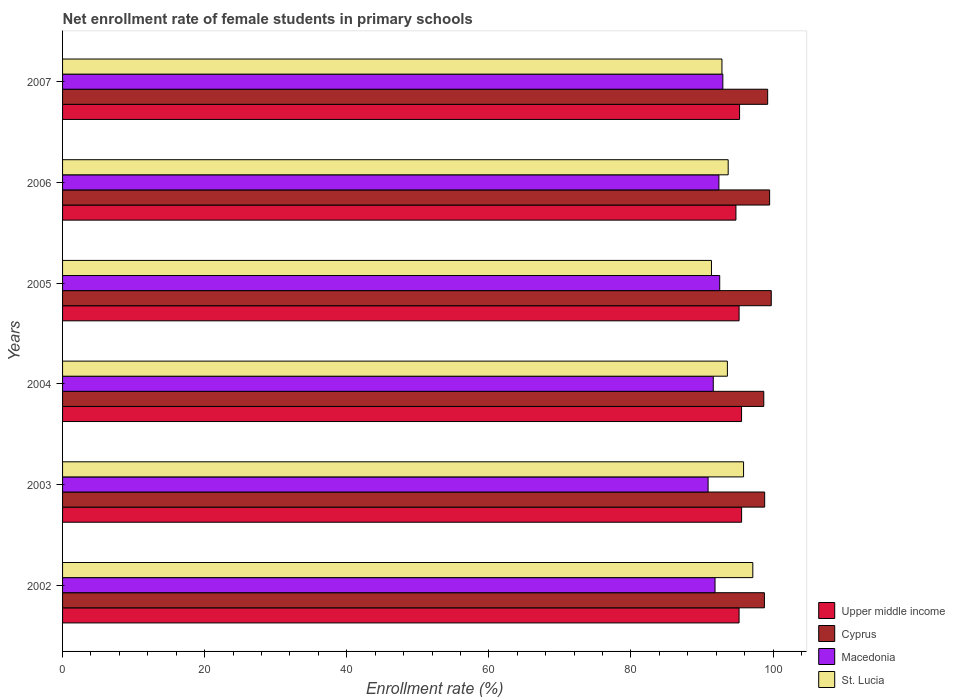How many groups of bars are there?
Offer a terse response. 6. Are the number of bars per tick equal to the number of legend labels?
Your answer should be very brief. Yes. How many bars are there on the 1st tick from the bottom?
Offer a very short reply. 4. What is the label of the 4th group of bars from the top?
Give a very brief answer. 2004. In how many cases, is the number of bars for a given year not equal to the number of legend labels?
Ensure brevity in your answer.  0. What is the net enrollment rate of female students in primary schools in Cyprus in 2003?
Ensure brevity in your answer.  98.82. Across all years, what is the maximum net enrollment rate of female students in primary schools in Cyprus?
Keep it short and to the point. 99.75. Across all years, what is the minimum net enrollment rate of female students in primary schools in Macedonia?
Make the answer very short. 90.86. In which year was the net enrollment rate of female students in primary schools in St. Lucia maximum?
Your answer should be compact. 2002. In which year was the net enrollment rate of female students in primary schools in Macedonia minimum?
Give a very brief answer. 2003. What is the total net enrollment rate of female students in primary schools in Macedonia in the graph?
Provide a succinct answer. 552.08. What is the difference between the net enrollment rate of female students in primary schools in St. Lucia in 2005 and that in 2007?
Ensure brevity in your answer.  -1.48. What is the difference between the net enrollment rate of female students in primary schools in St. Lucia in 2004 and the net enrollment rate of female students in primary schools in Macedonia in 2005?
Provide a short and direct response. 1.08. What is the average net enrollment rate of female students in primary schools in Macedonia per year?
Ensure brevity in your answer.  92.01. In the year 2002, what is the difference between the net enrollment rate of female students in primary schools in Macedonia and net enrollment rate of female students in primary schools in Cyprus?
Keep it short and to the point. -6.95. In how many years, is the net enrollment rate of female students in primary schools in St. Lucia greater than 44 %?
Offer a very short reply. 6. What is the ratio of the net enrollment rate of female students in primary schools in Macedonia in 2005 to that in 2007?
Offer a terse response. 1. Is the net enrollment rate of female students in primary schools in Cyprus in 2004 less than that in 2005?
Your response must be concise. Yes. Is the difference between the net enrollment rate of female students in primary schools in Macedonia in 2002 and 2005 greater than the difference between the net enrollment rate of female students in primary schools in Cyprus in 2002 and 2005?
Give a very brief answer. Yes. What is the difference between the highest and the second highest net enrollment rate of female students in primary schools in Upper middle income?
Offer a very short reply. 0.01. What is the difference between the highest and the lowest net enrollment rate of female students in primary schools in St. Lucia?
Make the answer very short. 5.82. Is the sum of the net enrollment rate of female students in primary schools in St. Lucia in 2003 and 2007 greater than the maximum net enrollment rate of female students in primary schools in Macedonia across all years?
Give a very brief answer. Yes. Is it the case that in every year, the sum of the net enrollment rate of female students in primary schools in St. Lucia and net enrollment rate of female students in primary schools in Cyprus is greater than the sum of net enrollment rate of female students in primary schools in Upper middle income and net enrollment rate of female students in primary schools in Macedonia?
Offer a very short reply. No. What does the 1st bar from the top in 2003 represents?
Ensure brevity in your answer.  St. Lucia. What does the 3rd bar from the bottom in 2002 represents?
Offer a very short reply. Macedonia. Is it the case that in every year, the sum of the net enrollment rate of female students in primary schools in St. Lucia and net enrollment rate of female students in primary schools in Macedonia is greater than the net enrollment rate of female students in primary schools in Cyprus?
Provide a short and direct response. Yes. How many bars are there?
Offer a terse response. 24. Are all the bars in the graph horizontal?
Your answer should be compact. Yes. How many years are there in the graph?
Give a very brief answer. 6. Does the graph contain any zero values?
Make the answer very short. No. Does the graph contain grids?
Make the answer very short. No. Where does the legend appear in the graph?
Ensure brevity in your answer.  Bottom right. How many legend labels are there?
Keep it short and to the point. 4. How are the legend labels stacked?
Ensure brevity in your answer.  Vertical. What is the title of the graph?
Ensure brevity in your answer.  Net enrollment rate of female students in primary schools. Does "Armenia" appear as one of the legend labels in the graph?
Make the answer very short. No. What is the label or title of the X-axis?
Keep it short and to the point. Enrollment rate (%). What is the Enrollment rate (%) in Upper middle income in 2002?
Keep it short and to the point. 95.22. What is the Enrollment rate (%) of Cyprus in 2002?
Your response must be concise. 98.78. What is the Enrollment rate (%) of Macedonia in 2002?
Offer a terse response. 91.83. What is the Enrollment rate (%) of St. Lucia in 2002?
Keep it short and to the point. 97.15. What is the Enrollment rate (%) of Upper middle income in 2003?
Ensure brevity in your answer.  95.57. What is the Enrollment rate (%) of Cyprus in 2003?
Offer a terse response. 98.82. What is the Enrollment rate (%) in Macedonia in 2003?
Your answer should be very brief. 90.86. What is the Enrollment rate (%) in St. Lucia in 2003?
Your answer should be very brief. 95.85. What is the Enrollment rate (%) of Upper middle income in 2004?
Provide a succinct answer. 95.57. What is the Enrollment rate (%) of Cyprus in 2004?
Offer a very short reply. 98.69. What is the Enrollment rate (%) in Macedonia in 2004?
Provide a short and direct response. 91.58. What is the Enrollment rate (%) of St. Lucia in 2004?
Keep it short and to the point. 93.57. What is the Enrollment rate (%) of Upper middle income in 2005?
Provide a short and direct response. 95.22. What is the Enrollment rate (%) of Cyprus in 2005?
Keep it short and to the point. 99.75. What is the Enrollment rate (%) in Macedonia in 2005?
Provide a short and direct response. 92.49. What is the Enrollment rate (%) in St. Lucia in 2005?
Your response must be concise. 91.33. What is the Enrollment rate (%) of Upper middle income in 2006?
Offer a very short reply. 94.77. What is the Enrollment rate (%) in Cyprus in 2006?
Provide a short and direct response. 99.52. What is the Enrollment rate (%) in Macedonia in 2006?
Your answer should be compact. 92.38. What is the Enrollment rate (%) of St. Lucia in 2006?
Your answer should be very brief. 93.68. What is the Enrollment rate (%) in Upper middle income in 2007?
Offer a very short reply. 95.29. What is the Enrollment rate (%) of Cyprus in 2007?
Give a very brief answer. 99.24. What is the Enrollment rate (%) in Macedonia in 2007?
Provide a succinct answer. 92.93. What is the Enrollment rate (%) of St. Lucia in 2007?
Ensure brevity in your answer.  92.81. Across all years, what is the maximum Enrollment rate (%) in Upper middle income?
Provide a succinct answer. 95.57. Across all years, what is the maximum Enrollment rate (%) of Cyprus?
Offer a very short reply. 99.75. Across all years, what is the maximum Enrollment rate (%) in Macedonia?
Your answer should be compact. 92.93. Across all years, what is the maximum Enrollment rate (%) in St. Lucia?
Keep it short and to the point. 97.15. Across all years, what is the minimum Enrollment rate (%) of Upper middle income?
Your answer should be compact. 94.77. Across all years, what is the minimum Enrollment rate (%) in Cyprus?
Give a very brief answer. 98.69. Across all years, what is the minimum Enrollment rate (%) in Macedonia?
Your answer should be very brief. 90.86. Across all years, what is the minimum Enrollment rate (%) in St. Lucia?
Your answer should be very brief. 91.33. What is the total Enrollment rate (%) in Upper middle income in the graph?
Offer a very short reply. 571.64. What is the total Enrollment rate (%) of Cyprus in the graph?
Your answer should be very brief. 594.8. What is the total Enrollment rate (%) of Macedonia in the graph?
Keep it short and to the point. 552.08. What is the total Enrollment rate (%) in St. Lucia in the graph?
Your response must be concise. 564.39. What is the difference between the Enrollment rate (%) of Upper middle income in 2002 and that in 2003?
Your answer should be very brief. -0.36. What is the difference between the Enrollment rate (%) in Cyprus in 2002 and that in 2003?
Your answer should be compact. -0.04. What is the difference between the Enrollment rate (%) in Macedonia in 2002 and that in 2003?
Your response must be concise. 0.97. What is the difference between the Enrollment rate (%) of St. Lucia in 2002 and that in 2003?
Offer a very short reply. 1.3. What is the difference between the Enrollment rate (%) of Upper middle income in 2002 and that in 2004?
Your answer should be very brief. -0.35. What is the difference between the Enrollment rate (%) in Cyprus in 2002 and that in 2004?
Your answer should be very brief. 0.09. What is the difference between the Enrollment rate (%) of Macedonia in 2002 and that in 2004?
Keep it short and to the point. 0.25. What is the difference between the Enrollment rate (%) of St. Lucia in 2002 and that in 2004?
Ensure brevity in your answer.  3.58. What is the difference between the Enrollment rate (%) in Upper middle income in 2002 and that in 2005?
Your response must be concise. -0. What is the difference between the Enrollment rate (%) of Cyprus in 2002 and that in 2005?
Ensure brevity in your answer.  -0.97. What is the difference between the Enrollment rate (%) in Macedonia in 2002 and that in 2005?
Keep it short and to the point. -0.66. What is the difference between the Enrollment rate (%) of St. Lucia in 2002 and that in 2005?
Provide a succinct answer. 5.82. What is the difference between the Enrollment rate (%) of Upper middle income in 2002 and that in 2006?
Provide a short and direct response. 0.44. What is the difference between the Enrollment rate (%) in Cyprus in 2002 and that in 2006?
Make the answer very short. -0.74. What is the difference between the Enrollment rate (%) of Macedonia in 2002 and that in 2006?
Keep it short and to the point. -0.55. What is the difference between the Enrollment rate (%) in St. Lucia in 2002 and that in 2006?
Offer a very short reply. 3.47. What is the difference between the Enrollment rate (%) in Upper middle income in 2002 and that in 2007?
Provide a short and direct response. -0.07. What is the difference between the Enrollment rate (%) of Cyprus in 2002 and that in 2007?
Give a very brief answer. -0.46. What is the difference between the Enrollment rate (%) of Macedonia in 2002 and that in 2007?
Ensure brevity in your answer.  -1.1. What is the difference between the Enrollment rate (%) of St. Lucia in 2002 and that in 2007?
Offer a very short reply. 4.34. What is the difference between the Enrollment rate (%) of Upper middle income in 2003 and that in 2004?
Make the answer very short. 0.01. What is the difference between the Enrollment rate (%) of Cyprus in 2003 and that in 2004?
Your answer should be very brief. 0.13. What is the difference between the Enrollment rate (%) in Macedonia in 2003 and that in 2004?
Keep it short and to the point. -0.73. What is the difference between the Enrollment rate (%) of St. Lucia in 2003 and that in 2004?
Keep it short and to the point. 2.28. What is the difference between the Enrollment rate (%) in Upper middle income in 2003 and that in 2005?
Make the answer very short. 0.35. What is the difference between the Enrollment rate (%) in Cyprus in 2003 and that in 2005?
Offer a terse response. -0.93. What is the difference between the Enrollment rate (%) in Macedonia in 2003 and that in 2005?
Your answer should be very brief. -1.63. What is the difference between the Enrollment rate (%) of St. Lucia in 2003 and that in 2005?
Provide a succinct answer. 4.52. What is the difference between the Enrollment rate (%) of Upper middle income in 2003 and that in 2006?
Provide a succinct answer. 0.8. What is the difference between the Enrollment rate (%) in Cyprus in 2003 and that in 2006?
Make the answer very short. -0.7. What is the difference between the Enrollment rate (%) in Macedonia in 2003 and that in 2006?
Keep it short and to the point. -1.52. What is the difference between the Enrollment rate (%) in St. Lucia in 2003 and that in 2006?
Make the answer very short. 2.17. What is the difference between the Enrollment rate (%) in Upper middle income in 2003 and that in 2007?
Give a very brief answer. 0.29. What is the difference between the Enrollment rate (%) in Cyprus in 2003 and that in 2007?
Your answer should be very brief. -0.42. What is the difference between the Enrollment rate (%) in Macedonia in 2003 and that in 2007?
Your response must be concise. -2.07. What is the difference between the Enrollment rate (%) in St. Lucia in 2003 and that in 2007?
Offer a very short reply. 3.04. What is the difference between the Enrollment rate (%) of Upper middle income in 2004 and that in 2005?
Keep it short and to the point. 0.35. What is the difference between the Enrollment rate (%) of Cyprus in 2004 and that in 2005?
Ensure brevity in your answer.  -1.05. What is the difference between the Enrollment rate (%) of Macedonia in 2004 and that in 2005?
Make the answer very short. -0.91. What is the difference between the Enrollment rate (%) of St. Lucia in 2004 and that in 2005?
Keep it short and to the point. 2.24. What is the difference between the Enrollment rate (%) in Upper middle income in 2004 and that in 2006?
Provide a succinct answer. 0.79. What is the difference between the Enrollment rate (%) of Cyprus in 2004 and that in 2006?
Give a very brief answer. -0.82. What is the difference between the Enrollment rate (%) of Macedonia in 2004 and that in 2006?
Your answer should be very brief. -0.79. What is the difference between the Enrollment rate (%) of St. Lucia in 2004 and that in 2006?
Make the answer very short. -0.11. What is the difference between the Enrollment rate (%) in Upper middle income in 2004 and that in 2007?
Provide a short and direct response. 0.28. What is the difference between the Enrollment rate (%) in Cyprus in 2004 and that in 2007?
Give a very brief answer. -0.55. What is the difference between the Enrollment rate (%) in Macedonia in 2004 and that in 2007?
Make the answer very short. -1.35. What is the difference between the Enrollment rate (%) of St. Lucia in 2004 and that in 2007?
Offer a terse response. 0.76. What is the difference between the Enrollment rate (%) of Upper middle income in 2005 and that in 2006?
Ensure brevity in your answer.  0.44. What is the difference between the Enrollment rate (%) in Cyprus in 2005 and that in 2006?
Your response must be concise. 0.23. What is the difference between the Enrollment rate (%) in Macedonia in 2005 and that in 2006?
Provide a succinct answer. 0.11. What is the difference between the Enrollment rate (%) of St. Lucia in 2005 and that in 2006?
Give a very brief answer. -2.35. What is the difference between the Enrollment rate (%) in Upper middle income in 2005 and that in 2007?
Your answer should be compact. -0.07. What is the difference between the Enrollment rate (%) of Cyprus in 2005 and that in 2007?
Your answer should be compact. 0.5. What is the difference between the Enrollment rate (%) of Macedonia in 2005 and that in 2007?
Keep it short and to the point. -0.44. What is the difference between the Enrollment rate (%) of St. Lucia in 2005 and that in 2007?
Your answer should be compact. -1.48. What is the difference between the Enrollment rate (%) of Upper middle income in 2006 and that in 2007?
Provide a succinct answer. -0.51. What is the difference between the Enrollment rate (%) of Cyprus in 2006 and that in 2007?
Offer a very short reply. 0.28. What is the difference between the Enrollment rate (%) in Macedonia in 2006 and that in 2007?
Your response must be concise. -0.55. What is the difference between the Enrollment rate (%) of St. Lucia in 2006 and that in 2007?
Your response must be concise. 0.88. What is the difference between the Enrollment rate (%) of Upper middle income in 2002 and the Enrollment rate (%) of Cyprus in 2003?
Offer a very short reply. -3.6. What is the difference between the Enrollment rate (%) in Upper middle income in 2002 and the Enrollment rate (%) in Macedonia in 2003?
Make the answer very short. 4.36. What is the difference between the Enrollment rate (%) of Upper middle income in 2002 and the Enrollment rate (%) of St. Lucia in 2003?
Ensure brevity in your answer.  -0.63. What is the difference between the Enrollment rate (%) in Cyprus in 2002 and the Enrollment rate (%) in Macedonia in 2003?
Offer a terse response. 7.92. What is the difference between the Enrollment rate (%) of Cyprus in 2002 and the Enrollment rate (%) of St. Lucia in 2003?
Make the answer very short. 2.93. What is the difference between the Enrollment rate (%) in Macedonia in 2002 and the Enrollment rate (%) in St. Lucia in 2003?
Your answer should be compact. -4.02. What is the difference between the Enrollment rate (%) of Upper middle income in 2002 and the Enrollment rate (%) of Cyprus in 2004?
Offer a terse response. -3.48. What is the difference between the Enrollment rate (%) of Upper middle income in 2002 and the Enrollment rate (%) of Macedonia in 2004?
Give a very brief answer. 3.63. What is the difference between the Enrollment rate (%) of Upper middle income in 2002 and the Enrollment rate (%) of St. Lucia in 2004?
Your answer should be compact. 1.65. What is the difference between the Enrollment rate (%) of Cyprus in 2002 and the Enrollment rate (%) of Macedonia in 2004?
Provide a succinct answer. 7.2. What is the difference between the Enrollment rate (%) in Cyprus in 2002 and the Enrollment rate (%) in St. Lucia in 2004?
Offer a terse response. 5.21. What is the difference between the Enrollment rate (%) of Macedonia in 2002 and the Enrollment rate (%) of St. Lucia in 2004?
Provide a succinct answer. -1.74. What is the difference between the Enrollment rate (%) of Upper middle income in 2002 and the Enrollment rate (%) of Cyprus in 2005?
Make the answer very short. -4.53. What is the difference between the Enrollment rate (%) in Upper middle income in 2002 and the Enrollment rate (%) in Macedonia in 2005?
Offer a terse response. 2.72. What is the difference between the Enrollment rate (%) in Upper middle income in 2002 and the Enrollment rate (%) in St. Lucia in 2005?
Give a very brief answer. 3.89. What is the difference between the Enrollment rate (%) of Cyprus in 2002 and the Enrollment rate (%) of Macedonia in 2005?
Your response must be concise. 6.29. What is the difference between the Enrollment rate (%) in Cyprus in 2002 and the Enrollment rate (%) in St. Lucia in 2005?
Make the answer very short. 7.45. What is the difference between the Enrollment rate (%) in Macedonia in 2002 and the Enrollment rate (%) in St. Lucia in 2005?
Offer a very short reply. 0.5. What is the difference between the Enrollment rate (%) in Upper middle income in 2002 and the Enrollment rate (%) in Macedonia in 2006?
Give a very brief answer. 2.84. What is the difference between the Enrollment rate (%) in Upper middle income in 2002 and the Enrollment rate (%) in St. Lucia in 2006?
Your response must be concise. 1.53. What is the difference between the Enrollment rate (%) in Cyprus in 2002 and the Enrollment rate (%) in Macedonia in 2006?
Your response must be concise. 6.4. What is the difference between the Enrollment rate (%) of Cyprus in 2002 and the Enrollment rate (%) of St. Lucia in 2006?
Provide a succinct answer. 5.1. What is the difference between the Enrollment rate (%) in Macedonia in 2002 and the Enrollment rate (%) in St. Lucia in 2006?
Your response must be concise. -1.85. What is the difference between the Enrollment rate (%) in Upper middle income in 2002 and the Enrollment rate (%) in Cyprus in 2007?
Ensure brevity in your answer.  -4.03. What is the difference between the Enrollment rate (%) in Upper middle income in 2002 and the Enrollment rate (%) in Macedonia in 2007?
Ensure brevity in your answer.  2.29. What is the difference between the Enrollment rate (%) of Upper middle income in 2002 and the Enrollment rate (%) of St. Lucia in 2007?
Make the answer very short. 2.41. What is the difference between the Enrollment rate (%) in Cyprus in 2002 and the Enrollment rate (%) in Macedonia in 2007?
Keep it short and to the point. 5.85. What is the difference between the Enrollment rate (%) in Cyprus in 2002 and the Enrollment rate (%) in St. Lucia in 2007?
Your answer should be compact. 5.97. What is the difference between the Enrollment rate (%) of Macedonia in 2002 and the Enrollment rate (%) of St. Lucia in 2007?
Provide a succinct answer. -0.97. What is the difference between the Enrollment rate (%) of Upper middle income in 2003 and the Enrollment rate (%) of Cyprus in 2004?
Ensure brevity in your answer.  -3.12. What is the difference between the Enrollment rate (%) in Upper middle income in 2003 and the Enrollment rate (%) in Macedonia in 2004?
Keep it short and to the point. 3.99. What is the difference between the Enrollment rate (%) of Upper middle income in 2003 and the Enrollment rate (%) of St. Lucia in 2004?
Give a very brief answer. 2. What is the difference between the Enrollment rate (%) in Cyprus in 2003 and the Enrollment rate (%) in Macedonia in 2004?
Offer a terse response. 7.24. What is the difference between the Enrollment rate (%) of Cyprus in 2003 and the Enrollment rate (%) of St. Lucia in 2004?
Your answer should be compact. 5.25. What is the difference between the Enrollment rate (%) of Macedonia in 2003 and the Enrollment rate (%) of St. Lucia in 2004?
Your answer should be compact. -2.71. What is the difference between the Enrollment rate (%) of Upper middle income in 2003 and the Enrollment rate (%) of Cyprus in 2005?
Provide a short and direct response. -4.17. What is the difference between the Enrollment rate (%) of Upper middle income in 2003 and the Enrollment rate (%) of Macedonia in 2005?
Provide a short and direct response. 3.08. What is the difference between the Enrollment rate (%) in Upper middle income in 2003 and the Enrollment rate (%) in St. Lucia in 2005?
Make the answer very short. 4.24. What is the difference between the Enrollment rate (%) of Cyprus in 2003 and the Enrollment rate (%) of Macedonia in 2005?
Your answer should be very brief. 6.33. What is the difference between the Enrollment rate (%) in Cyprus in 2003 and the Enrollment rate (%) in St. Lucia in 2005?
Provide a succinct answer. 7.49. What is the difference between the Enrollment rate (%) in Macedonia in 2003 and the Enrollment rate (%) in St. Lucia in 2005?
Provide a short and direct response. -0.47. What is the difference between the Enrollment rate (%) of Upper middle income in 2003 and the Enrollment rate (%) of Cyprus in 2006?
Ensure brevity in your answer.  -3.94. What is the difference between the Enrollment rate (%) in Upper middle income in 2003 and the Enrollment rate (%) in Macedonia in 2006?
Provide a succinct answer. 3.19. What is the difference between the Enrollment rate (%) of Upper middle income in 2003 and the Enrollment rate (%) of St. Lucia in 2006?
Provide a short and direct response. 1.89. What is the difference between the Enrollment rate (%) of Cyprus in 2003 and the Enrollment rate (%) of Macedonia in 2006?
Ensure brevity in your answer.  6.44. What is the difference between the Enrollment rate (%) of Cyprus in 2003 and the Enrollment rate (%) of St. Lucia in 2006?
Ensure brevity in your answer.  5.14. What is the difference between the Enrollment rate (%) in Macedonia in 2003 and the Enrollment rate (%) in St. Lucia in 2006?
Provide a succinct answer. -2.83. What is the difference between the Enrollment rate (%) in Upper middle income in 2003 and the Enrollment rate (%) in Cyprus in 2007?
Provide a short and direct response. -3.67. What is the difference between the Enrollment rate (%) in Upper middle income in 2003 and the Enrollment rate (%) in Macedonia in 2007?
Ensure brevity in your answer.  2.64. What is the difference between the Enrollment rate (%) in Upper middle income in 2003 and the Enrollment rate (%) in St. Lucia in 2007?
Your answer should be very brief. 2.77. What is the difference between the Enrollment rate (%) of Cyprus in 2003 and the Enrollment rate (%) of Macedonia in 2007?
Give a very brief answer. 5.89. What is the difference between the Enrollment rate (%) of Cyprus in 2003 and the Enrollment rate (%) of St. Lucia in 2007?
Provide a short and direct response. 6.01. What is the difference between the Enrollment rate (%) in Macedonia in 2003 and the Enrollment rate (%) in St. Lucia in 2007?
Make the answer very short. -1.95. What is the difference between the Enrollment rate (%) of Upper middle income in 2004 and the Enrollment rate (%) of Cyprus in 2005?
Your response must be concise. -4.18. What is the difference between the Enrollment rate (%) in Upper middle income in 2004 and the Enrollment rate (%) in Macedonia in 2005?
Your answer should be very brief. 3.07. What is the difference between the Enrollment rate (%) in Upper middle income in 2004 and the Enrollment rate (%) in St. Lucia in 2005?
Offer a very short reply. 4.24. What is the difference between the Enrollment rate (%) in Cyprus in 2004 and the Enrollment rate (%) in Macedonia in 2005?
Give a very brief answer. 6.2. What is the difference between the Enrollment rate (%) in Cyprus in 2004 and the Enrollment rate (%) in St. Lucia in 2005?
Your answer should be compact. 7.36. What is the difference between the Enrollment rate (%) of Macedonia in 2004 and the Enrollment rate (%) of St. Lucia in 2005?
Keep it short and to the point. 0.25. What is the difference between the Enrollment rate (%) of Upper middle income in 2004 and the Enrollment rate (%) of Cyprus in 2006?
Offer a very short reply. -3.95. What is the difference between the Enrollment rate (%) in Upper middle income in 2004 and the Enrollment rate (%) in Macedonia in 2006?
Make the answer very short. 3.19. What is the difference between the Enrollment rate (%) in Upper middle income in 2004 and the Enrollment rate (%) in St. Lucia in 2006?
Your answer should be very brief. 1.88. What is the difference between the Enrollment rate (%) of Cyprus in 2004 and the Enrollment rate (%) of Macedonia in 2006?
Provide a short and direct response. 6.32. What is the difference between the Enrollment rate (%) in Cyprus in 2004 and the Enrollment rate (%) in St. Lucia in 2006?
Your response must be concise. 5.01. What is the difference between the Enrollment rate (%) in Macedonia in 2004 and the Enrollment rate (%) in St. Lucia in 2006?
Keep it short and to the point. -2.1. What is the difference between the Enrollment rate (%) in Upper middle income in 2004 and the Enrollment rate (%) in Cyprus in 2007?
Give a very brief answer. -3.68. What is the difference between the Enrollment rate (%) in Upper middle income in 2004 and the Enrollment rate (%) in Macedonia in 2007?
Your answer should be compact. 2.63. What is the difference between the Enrollment rate (%) in Upper middle income in 2004 and the Enrollment rate (%) in St. Lucia in 2007?
Give a very brief answer. 2.76. What is the difference between the Enrollment rate (%) in Cyprus in 2004 and the Enrollment rate (%) in Macedonia in 2007?
Offer a very short reply. 5.76. What is the difference between the Enrollment rate (%) of Cyprus in 2004 and the Enrollment rate (%) of St. Lucia in 2007?
Provide a short and direct response. 5.89. What is the difference between the Enrollment rate (%) of Macedonia in 2004 and the Enrollment rate (%) of St. Lucia in 2007?
Provide a short and direct response. -1.22. What is the difference between the Enrollment rate (%) in Upper middle income in 2005 and the Enrollment rate (%) in Cyprus in 2006?
Provide a succinct answer. -4.3. What is the difference between the Enrollment rate (%) in Upper middle income in 2005 and the Enrollment rate (%) in Macedonia in 2006?
Provide a succinct answer. 2.84. What is the difference between the Enrollment rate (%) in Upper middle income in 2005 and the Enrollment rate (%) in St. Lucia in 2006?
Ensure brevity in your answer.  1.53. What is the difference between the Enrollment rate (%) in Cyprus in 2005 and the Enrollment rate (%) in Macedonia in 2006?
Ensure brevity in your answer.  7.37. What is the difference between the Enrollment rate (%) in Cyprus in 2005 and the Enrollment rate (%) in St. Lucia in 2006?
Your answer should be very brief. 6.06. What is the difference between the Enrollment rate (%) in Macedonia in 2005 and the Enrollment rate (%) in St. Lucia in 2006?
Make the answer very short. -1.19. What is the difference between the Enrollment rate (%) of Upper middle income in 2005 and the Enrollment rate (%) of Cyprus in 2007?
Your answer should be compact. -4.02. What is the difference between the Enrollment rate (%) of Upper middle income in 2005 and the Enrollment rate (%) of Macedonia in 2007?
Ensure brevity in your answer.  2.29. What is the difference between the Enrollment rate (%) in Upper middle income in 2005 and the Enrollment rate (%) in St. Lucia in 2007?
Your response must be concise. 2.41. What is the difference between the Enrollment rate (%) of Cyprus in 2005 and the Enrollment rate (%) of Macedonia in 2007?
Provide a short and direct response. 6.82. What is the difference between the Enrollment rate (%) of Cyprus in 2005 and the Enrollment rate (%) of St. Lucia in 2007?
Make the answer very short. 6.94. What is the difference between the Enrollment rate (%) of Macedonia in 2005 and the Enrollment rate (%) of St. Lucia in 2007?
Offer a terse response. -0.31. What is the difference between the Enrollment rate (%) of Upper middle income in 2006 and the Enrollment rate (%) of Cyprus in 2007?
Make the answer very short. -4.47. What is the difference between the Enrollment rate (%) in Upper middle income in 2006 and the Enrollment rate (%) in Macedonia in 2007?
Provide a short and direct response. 1.84. What is the difference between the Enrollment rate (%) in Upper middle income in 2006 and the Enrollment rate (%) in St. Lucia in 2007?
Your answer should be compact. 1.97. What is the difference between the Enrollment rate (%) in Cyprus in 2006 and the Enrollment rate (%) in Macedonia in 2007?
Your answer should be very brief. 6.59. What is the difference between the Enrollment rate (%) in Cyprus in 2006 and the Enrollment rate (%) in St. Lucia in 2007?
Make the answer very short. 6.71. What is the difference between the Enrollment rate (%) of Macedonia in 2006 and the Enrollment rate (%) of St. Lucia in 2007?
Keep it short and to the point. -0.43. What is the average Enrollment rate (%) of Upper middle income per year?
Your answer should be compact. 95.27. What is the average Enrollment rate (%) in Cyprus per year?
Provide a succinct answer. 99.13. What is the average Enrollment rate (%) in Macedonia per year?
Your response must be concise. 92.01. What is the average Enrollment rate (%) of St. Lucia per year?
Your response must be concise. 94.07. In the year 2002, what is the difference between the Enrollment rate (%) in Upper middle income and Enrollment rate (%) in Cyprus?
Ensure brevity in your answer.  -3.56. In the year 2002, what is the difference between the Enrollment rate (%) in Upper middle income and Enrollment rate (%) in Macedonia?
Your answer should be compact. 3.38. In the year 2002, what is the difference between the Enrollment rate (%) in Upper middle income and Enrollment rate (%) in St. Lucia?
Provide a short and direct response. -1.93. In the year 2002, what is the difference between the Enrollment rate (%) of Cyprus and Enrollment rate (%) of Macedonia?
Provide a succinct answer. 6.95. In the year 2002, what is the difference between the Enrollment rate (%) in Cyprus and Enrollment rate (%) in St. Lucia?
Offer a very short reply. 1.63. In the year 2002, what is the difference between the Enrollment rate (%) in Macedonia and Enrollment rate (%) in St. Lucia?
Provide a succinct answer. -5.32. In the year 2003, what is the difference between the Enrollment rate (%) of Upper middle income and Enrollment rate (%) of Cyprus?
Your response must be concise. -3.25. In the year 2003, what is the difference between the Enrollment rate (%) of Upper middle income and Enrollment rate (%) of Macedonia?
Keep it short and to the point. 4.71. In the year 2003, what is the difference between the Enrollment rate (%) of Upper middle income and Enrollment rate (%) of St. Lucia?
Your answer should be compact. -0.28. In the year 2003, what is the difference between the Enrollment rate (%) of Cyprus and Enrollment rate (%) of Macedonia?
Provide a succinct answer. 7.96. In the year 2003, what is the difference between the Enrollment rate (%) in Cyprus and Enrollment rate (%) in St. Lucia?
Offer a very short reply. 2.97. In the year 2003, what is the difference between the Enrollment rate (%) in Macedonia and Enrollment rate (%) in St. Lucia?
Keep it short and to the point. -4.99. In the year 2004, what is the difference between the Enrollment rate (%) of Upper middle income and Enrollment rate (%) of Cyprus?
Make the answer very short. -3.13. In the year 2004, what is the difference between the Enrollment rate (%) in Upper middle income and Enrollment rate (%) in Macedonia?
Your response must be concise. 3.98. In the year 2004, what is the difference between the Enrollment rate (%) in Upper middle income and Enrollment rate (%) in St. Lucia?
Keep it short and to the point. 2. In the year 2004, what is the difference between the Enrollment rate (%) of Cyprus and Enrollment rate (%) of Macedonia?
Your answer should be very brief. 7.11. In the year 2004, what is the difference between the Enrollment rate (%) in Cyprus and Enrollment rate (%) in St. Lucia?
Make the answer very short. 5.12. In the year 2004, what is the difference between the Enrollment rate (%) of Macedonia and Enrollment rate (%) of St. Lucia?
Keep it short and to the point. -1.99. In the year 2005, what is the difference between the Enrollment rate (%) in Upper middle income and Enrollment rate (%) in Cyprus?
Ensure brevity in your answer.  -4.53. In the year 2005, what is the difference between the Enrollment rate (%) in Upper middle income and Enrollment rate (%) in Macedonia?
Your response must be concise. 2.73. In the year 2005, what is the difference between the Enrollment rate (%) of Upper middle income and Enrollment rate (%) of St. Lucia?
Offer a very short reply. 3.89. In the year 2005, what is the difference between the Enrollment rate (%) in Cyprus and Enrollment rate (%) in Macedonia?
Your answer should be compact. 7.25. In the year 2005, what is the difference between the Enrollment rate (%) in Cyprus and Enrollment rate (%) in St. Lucia?
Offer a terse response. 8.42. In the year 2005, what is the difference between the Enrollment rate (%) of Macedonia and Enrollment rate (%) of St. Lucia?
Your response must be concise. 1.16. In the year 2006, what is the difference between the Enrollment rate (%) of Upper middle income and Enrollment rate (%) of Cyprus?
Give a very brief answer. -4.74. In the year 2006, what is the difference between the Enrollment rate (%) in Upper middle income and Enrollment rate (%) in Macedonia?
Your response must be concise. 2.4. In the year 2006, what is the difference between the Enrollment rate (%) in Upper middle income and Enrollment rate (%) in St. Lucia?
Your answer should be compact. 1.09. In the year 2006, what is the difference between the Enrollment rate (%) of Cyprus and Enrollment rate (%) of Macedonia?
Offer a terse response. 7.14. In the year 2006, what is the difference between the Enrollment rate (%) of Cyprus and Enrollment rate (%) of St. Lucia?
Make the answer very short. 5.83. In the year 2006, what is the difference between the Enrollment rate (%) of Macedonia and Enrollment rate (%) of St. Lucia?
Offer a terse response. -1.3. In the year 2007, what is the difference between the Enrollment rate (%) of Upper middle income and Enrollment rate (%) of Cyprus?
Keep it short and to the point. -3.95. In the year 2007, what is the difference between the Enrollment rate (%) of Upper middle income and Enrollment rate (%) of Macedonia?
Your response must be concise. 2.36. In the year 2007, what is the difference between the Enrollment rate (%) of Upper middle income and Enrollment rate (%) of St. Lucia?
Ensure brevity in your answer.  2.48. In the year 2007, what is the difference between the Enrollment rate (%) of Cyprus and Enrollment rate (%) of Macedonia?
Ensure brevity in your answer.  6.31. In the year 2007, what is the difference between the Enrollment rate (%) in Cyprus and Enrollment rate (%) in St. Lucia?
Provide a succinct answer. 6.44. In the year 2007, what is the difference between the Enrollment rate (%) in Macedonia and Enrollment rate (%) in St. Lucia?
Your response must be concise. 0.12. What is the ratio of the Enrollment rate (%) of Macedonia in 2002 to that in 2003?
Your answer should be compact. 1.01. What is the ratio of the Enrollment rate (%) in St. Lucia in 2002 to that in 2003?
Your answer should be compact. 1.01. What is the ratio of the Enrollment rate (%) in Cyprus in 2002 to that in 2004?
Give a very brief answer. 1. What is the ratio of the Enrollment rate (%) of St. Lucia in 2002 to that in 2004?
Your answer should be very brief. 1.04. What is the ratio of the Enrollment rate (%) in Cyprus in 2002 to that in 2005?
Offer a terse response. 0.99. What is the ratio of the Enrollment rate (%) of St. Lucia in 2002 to that in 2005?
Provide a short and direct response. 1.06. What is the ratio of the Enrollment rate (%) of Macedonia in 2002 to that in 2006?
Make the answer very short. 0.99. What is the ratio of the Enrollment rate (%) in St. Lucia in 2002 to that in 2006?
Your answer should be compact. 1.04. What is the ratio of the Enrollment rate (%) in Upper middle income in 2002 to that in 2007?
Give a very brief answer. 1. What is the ratio of the Enrollment rate (%) of Macedonia in 2002 to that in 2007?
Offer a terse response. 0.99. What is the ratio of the Enrollment rate (%) in St. Lucia in 2002 to that in 2007?
Your answer should be very brief. 1.05. What is the ratio of the Enrollment rate (%) of Macedonia in 2003 to that in 2004?
Your response must be concise. 0.99. What is the ratio of the Enrollment rate (%) of St. Lucia in 2003 to that in 2004?
Your response must be concise. 1.02. What is the ratio of the Enrollment rate (%) in Cyprus in 2003 to that in 2005?
Make the answer very short. 0.99. What is the ratio of the Enrollment rate (%) in Macedonia in 2003 to that in 2005?
Offer a very short reply. 0.98. What is the ratio of the Enrollment rate (%) of St. Lucia in 2003 to that in 2005?
Your answer should be compact. 1.05. What is the ratio of the Enrollment rate (%) of Upper middle income in 2003 to that in 2006?
Offer a terse response. 1.01. What is the ratio of the Enrollment rate (%) of Cyprus in 2003 to that in 2006?
Ensure brevity in your answer.  0.99. What is the ratio of the Enrollment rate (%) of Macedonia in 2003 to that in 2006?
Provide a short and direct response. 0.98. What is the ratio of the Enrollment rate (%) in St. Lucia in 2003 to that in 2006?
Provide a succinct answer. 1.02. What is the ratio of the Enrollment rate (%) in Macedonia in 2003 to that in 2007?
Make the answer very short. 0.98. What is the ratio of the Enrollment rate (%) of St. Lucia in 2003 to that in 2007?
Give a very brief answer. 1.03. What is the ratio of the Enrollment rate (%) of Cyprus in 2004 to that in 2005?
Offer a very short reply. 0.99. What is the ratio of the Enrollment rate (%) of Macedonia in 2004 to that in 2005?
Your answer should be compact. 0.99. What is the ratio of the Enrollment rate (%) in St. Lucia in 2004 to that in 2005?
Provide a succinct answer. 1.02. What is the ratio of the Enrollment rate (%) of Upper middle income in 2004 to that in 2006?
Your answer should be very brief. 1.01. What is the ratio of the Enrollment rate (%) in Macedonia in 2004 to that in 2006?
Ensure brevity in your answer.  0.99. What is the ratio of the Enrollment rate (%) in St. Lucia in 2004 to that in 2006?
Provide a succinct answer. 1. What is the ratio of the Enrollment rate (%) in Upper middle income in 2004 to that in 2007?
Your answer should be very brief. 1. What is the ratio of the Enrollment rate (%) of Macedonia in 2004 to that in 2007?
Offer a very short reply. 0.99. What is the ratio of the Enrollment rate (%) in St. Lucia in 2004 to that in 2007?
Offer a very short reply. 1.01. What is the ratio of the Enrollment rate (%) in St. Lucia in 2005 to that in 2006?
Provide a short and direct response. 0.97. What is the ratio of the Enrollment rate (%) of St. Lucia in 2005 to that in 2007?
Offer a terse response. 0.98. What is the ratio of the Enrollment rate (%) in Upper middle income in 2006 to that in 2007?
Your answer should be very brief. 0.99. What is the ratio of the Enrollment rate (%) in Macedonia in 2006 to that in 2007?
Provide a short and direct response. 0.99. What is the ratio of the Enrollment rate (%) in St. Lucia in 2006 to that in 2007?
Provide a succinct answer. 1.01. What is the difference between the highest and the second highest Enrollment rate (%) in Upper middle income?
Make the answer very short. 0.01. What is the difference between the highest and the second highest Enrollment rate (%) of Cyprus?
Your answer should be compact. 0.23. What is the difference between the highest and the second highest Enrollment rate (%) of Macedonia?
Your response must be concise. 0.44. What is the difference between the highest and the second highest Enrollment rate (%) in St. Lucia?
Offer a terse response. 1.3. What is the difference between the highest and the lowest Enrollment rate (%) of Upper middle income?
Your answer should be compact. 0.8. What is the difference between the highest and the lowest Enrollment rate (%) in Cyprus?
Give a very brief answer. 1.05. What is the difference between the highest and the lowest Enrollment rate (%) of Macedonia?
Offer a very short reply. 2.07. What is the difference between the highest and the lowest Enrollment rate (%) of St. Lucia?
Keep it short and to the point. 5.82. 